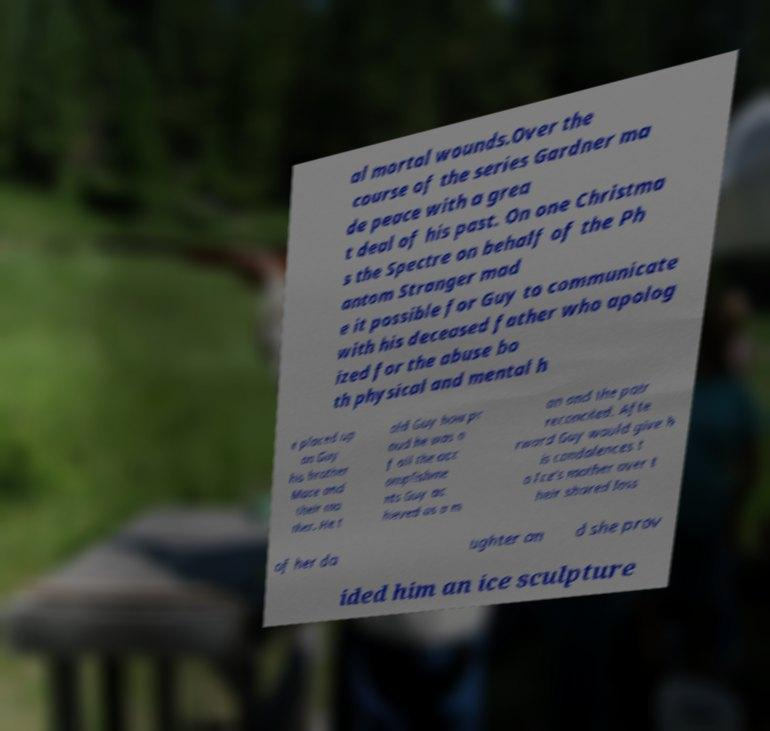I need the written content from this picture converted into text. Can you do that? al mortal wounds.Over the course of the series Gardner ma de peace with a grea t deal of his past. On one Christma s the Spectre on behalf of the Ph antom Stranger mad e it possible for Guy to communicate with his deceased father who apolog ized for the abuse bo th physical and mental h e placed up on Guy his brother Mace and their mo ther. He t old Guy how pr oud he was o f all the acc omplishme nts Guy ac hieved as a m an and the pair reconciled. Afte rward Guy would give h is condolences t o Ice's mother over t heir shared loss of her da ughter an d she prov ided him an ice sculpture 